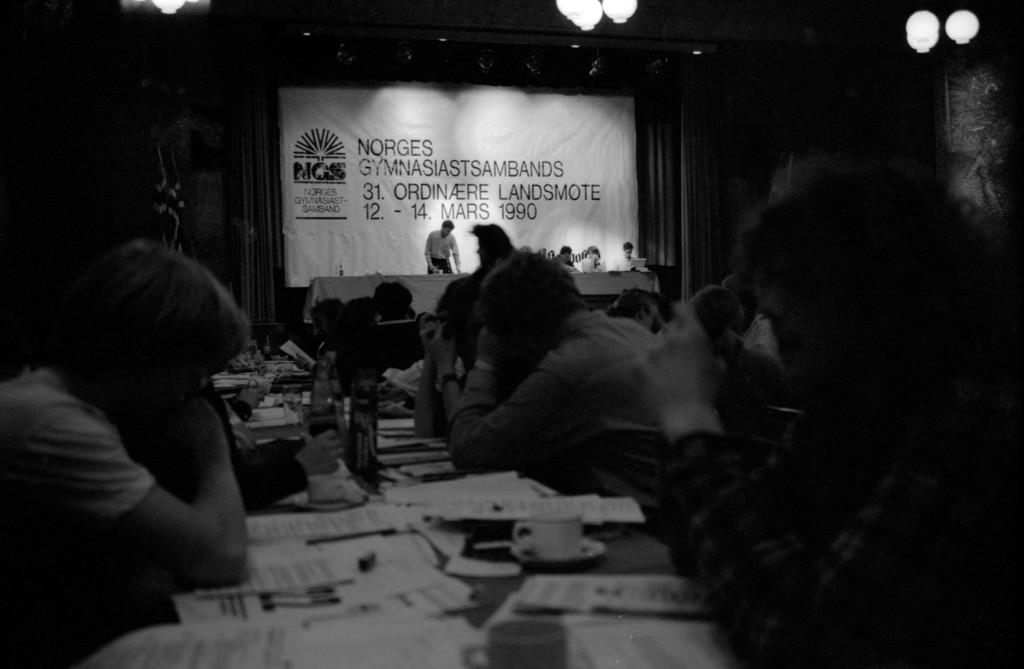How many people are in the image? There are multiple people in the image. What are the people doing in the image? One man is standing, and the rest of the people are sitting. What objects can be seen on the tables in the image? There are papers, bottles, and a cup on the tables. What type of club is being used by the people in the image? There is no club present in the image. Are the people wearing stockings in the image? There is no information about the clothing of the people in the image, so it cannot be determined if they are wearing stockings. 